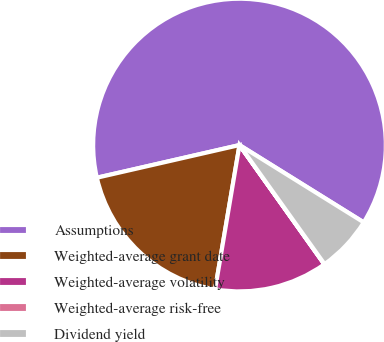Convert chart to OTSL. <chart><loc_0><loc_0><loc_500><loc_500><pie_chart><fcel>Assumptions<fcel>Weighted-average grant date<fcel>Weighted-average volatility<fcel>Weighted-average risk-free<fcel>Dividend yield<nl><fcel>62.44%<fcel>18.75%<fcel>12.51%<fcel>0.03%<fcel>6.27%<nl></chart> 